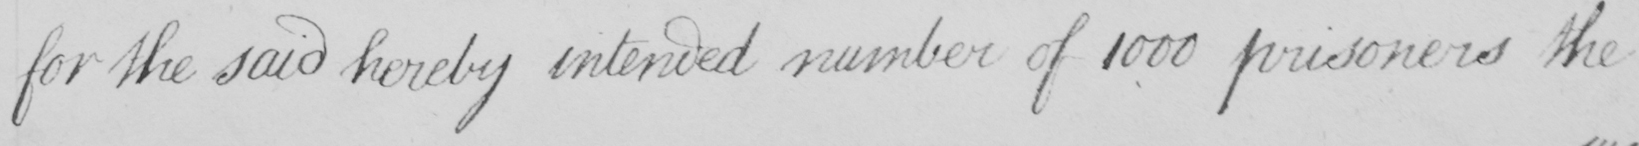Can you read and transcribe this handwriting? for the said hereby intended number of 1000 prisoners the 